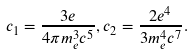<formula> <loc_0><loc_0><loc_500><loc_500>c _ { 1 } = \frac { 3 e } { 4 \pi m _ { e } ^ { 3 } c ^ { 5 } } , c _ { 2 } = \frac { 2 e ^ { 4 } } { 3 m _ { e } ^ { 4 } c ^ { 7 } } .</formula> 